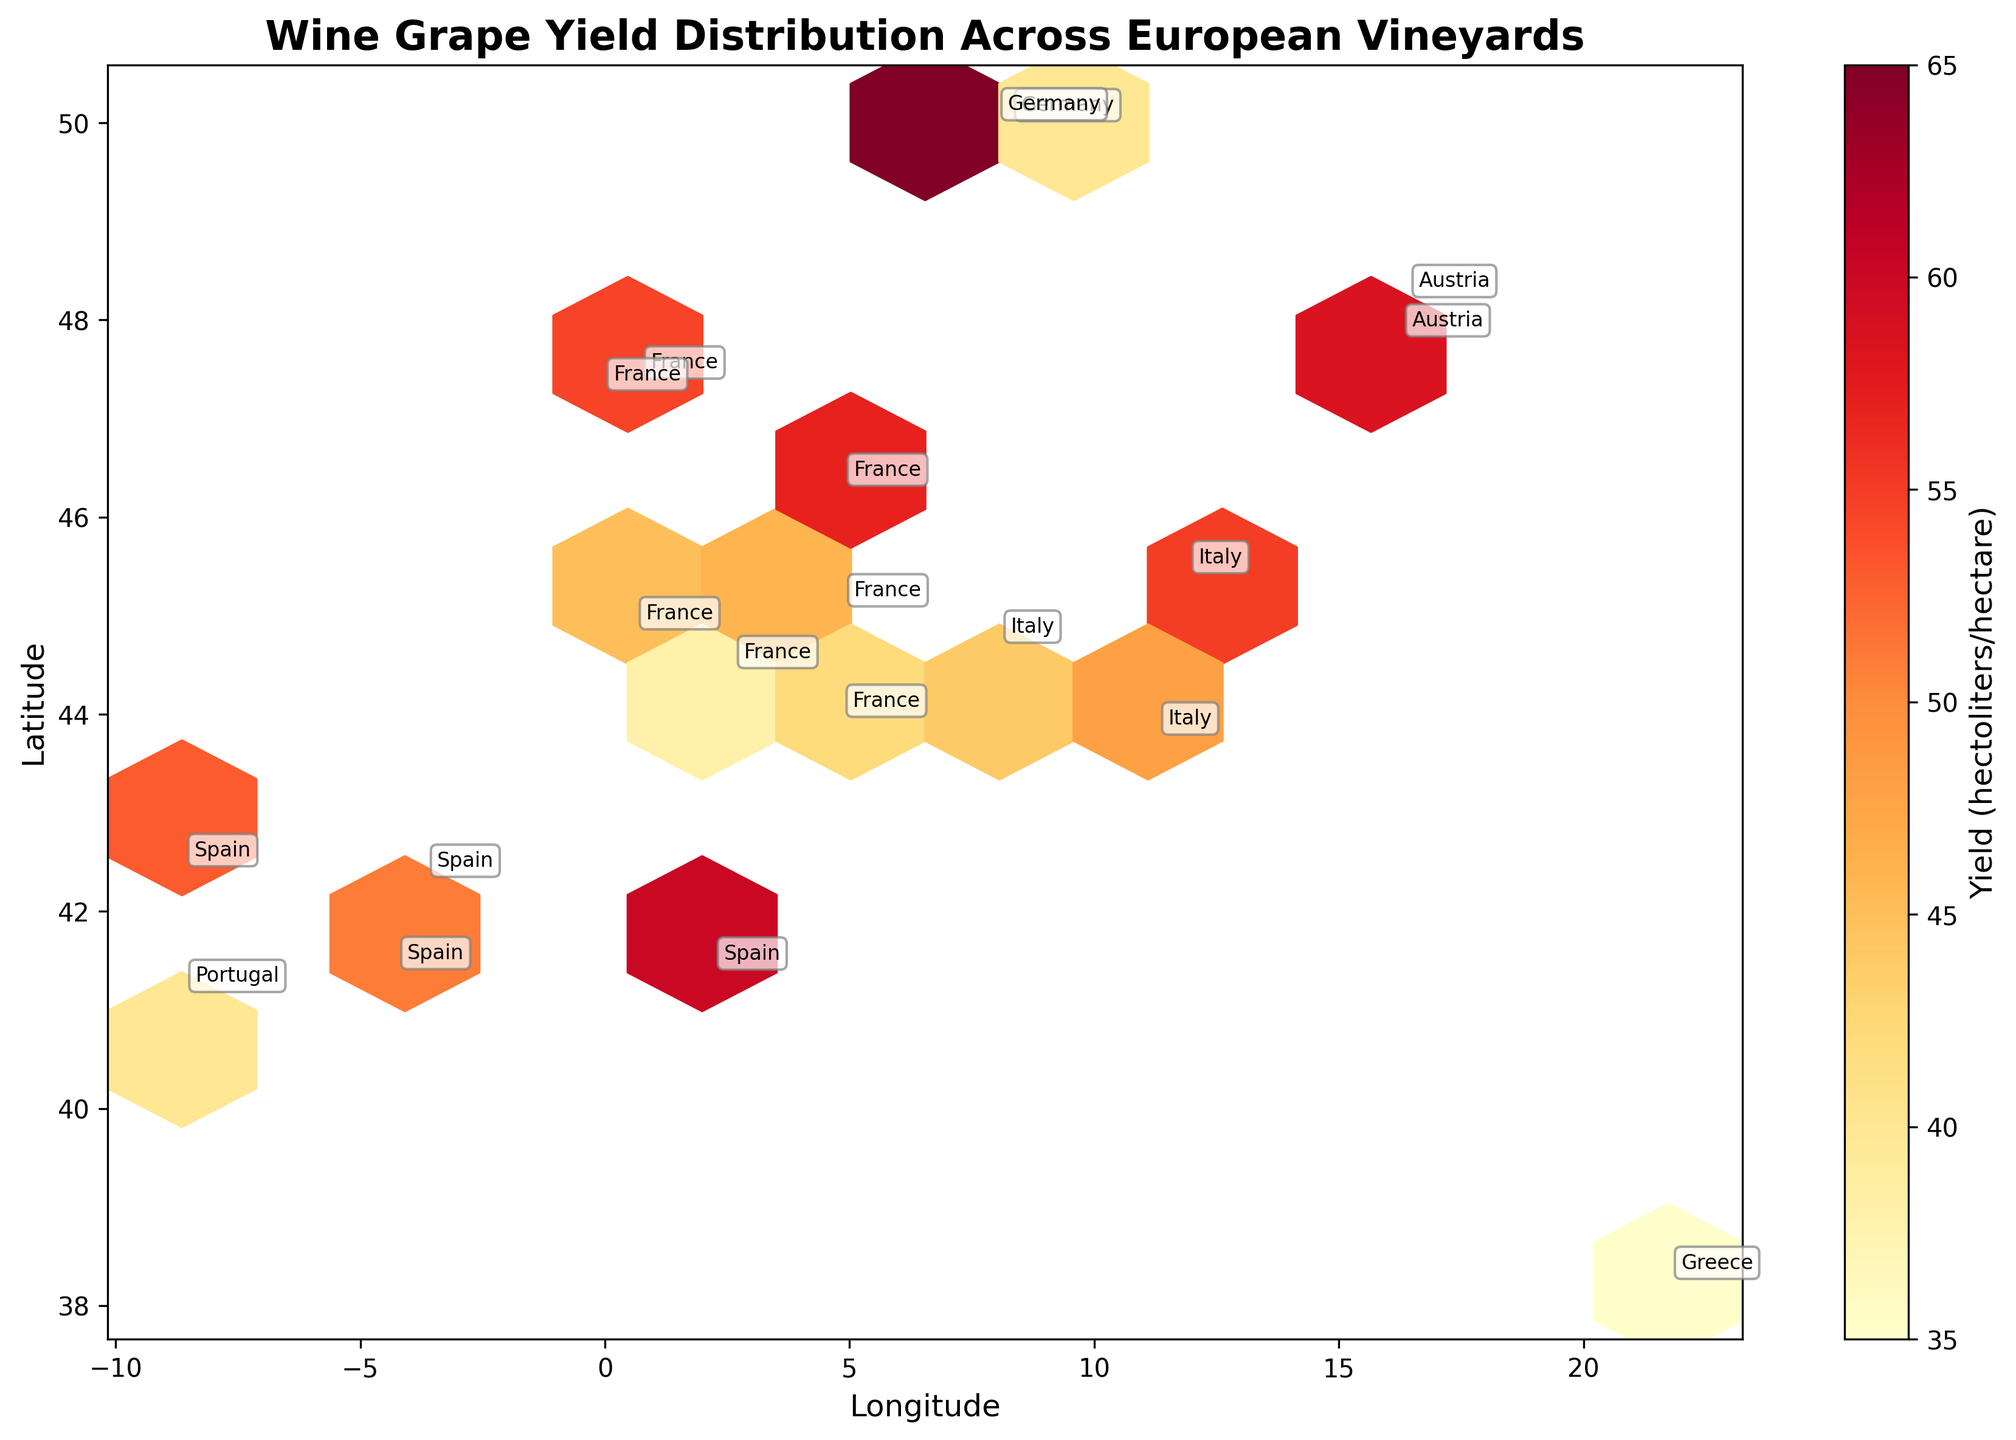What is the title of the plot? The title is located at the top of the plot, which summarizes the main topic of the visualization.
Answer: Wine Grape Yield Distribution Across European Vineyards What do the colors represent in the hexbin plot? The colors denote different yield levels per hectare, based on a color scale indicated by the colorbar on the side.
Answer: Yield (hectoliters/hectare) Where are Cabernet Sauvignon vineyards located? By identifying the labeled points corresponding to Cabernet Sauvignon, we can locate these vineyards.
Answer: France (Longitude: 0.5792, Latitude: 44.8378) Which country has the highest yield per hectare indicated on the plot? Examining the annotated labels and cross-referencing with the color intensity, the country with the darkest hue will have the highest yield per hectare.
Answer: Germany (with yield of Riesling) What are the approximate longitude and latitude ranges for vineyards in this figure? Observe the x and y axes for the approximate stretch of longitudes and latitudes covered by the data points.
Answer: Longitude: -8.6 to 16.4, Latitude: 38.2 to 50.0 Compare the yields of Sauvignon Blanc and Sangiovese. Which one has a higher yield? Locate the annotations for both grape varieties and compare the shades of their hexagons. Sauvignon Blanc will have a darker shade if its yield is higher.
Answer: Sauvignon Blanc (58) is higher than Sangiovese (48) What is the yield range for the hexagonal bins shown? Referencing the colorbar, note the range from the lightest to the darkest hue which indicates the lowest to the highest yields.
Answer: Approximately 35 to 65 hectoliters/hectare Which vineyard entries are closest to the central latitude of Europe (around 47°)? Identify data points around the central latitude value, considering the annotations. Compare distances to pinpoint the closest entries.
Answer: Sauvignon Blanc, Chenin Blanc, Zweigelt Which grape variety has the lowest yield in the plot? Seek the lightest shaded hexagon in the plot and cross-reference with the grape variety annotation.
Answer: Syrah (35 hectoliters/hectare) How many data points (grape varieties) are presented in the figure? Count the number of annotations (names of grape varieties) shown in the plot to deduce the number of data points.
Answer: 19 